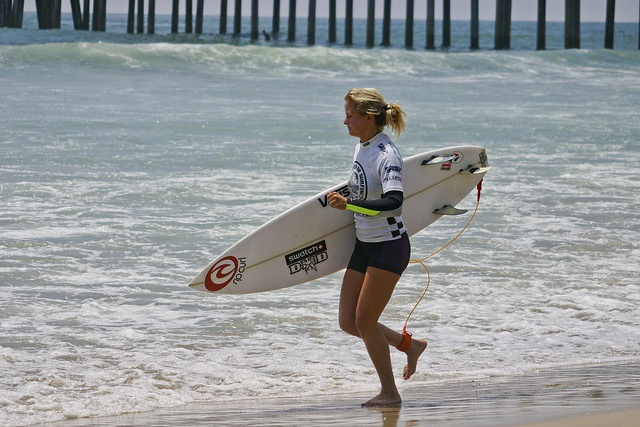Describe the objects in this image and their specific colors. I can see surfboard in black, gray, and darkgray tones and people in black, maroon, gray, and darkgray tones in this image. 